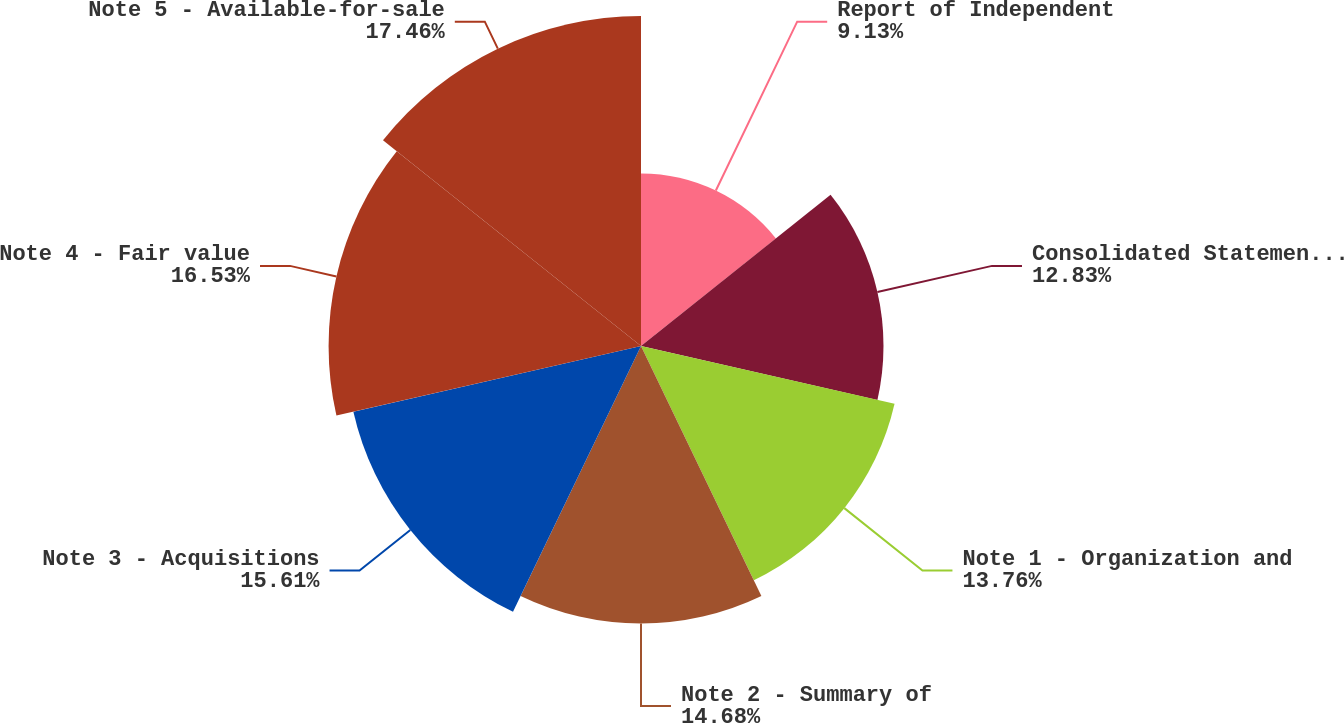<chart> <loc_0><loc_0><loc_500><loc_500><pie_chart><fcel>Report of Independent<fcel>Consolidated Statements of<fcel>Note 1 - Organization and<fcel>Note 2 - Summary of<fcel>Note 3 - Acquisitions<fcel>Note 4 - Fair value<fcel>Note 5 - Available-for-sale<nl><fcel>9.13%<fcel>12.83%<fcel>13.76%<fcel>14.68%<fcel>15.61%<fcel>16.53%<fcel>17.46%<nl></chart> 